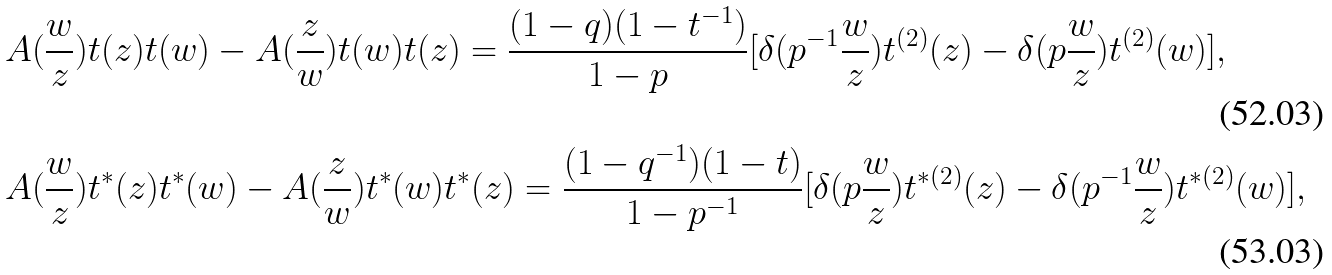Convert formula to latex. <formula><loc_0><loc_0><loc_500><loc_500>& A ( \frac { w } { z } ) t ( z ) t ( w ) - A ( \frac { z } { w } ) t ( w ) t ( z ) = \frac { ( 1 - q ) ( 1 - t ^ { - 1 } ) } { 1 - p } [ \delta ( p ^ { - 1 } \frac { w } { z } ) t ^ { ( 2 ) } ( z ) - \delta ( p \frac { w } { z } ) t ^ { ( 2 ) } ( w ) ] , \\ & A ( \frac { w } { z } ) t ^ { * } ( z ) t ^ { * } ( w ) - A ( \frac { z } { w } ) t ^ { * } ( w ) t ^ { * } ( z ) = \frac { ( 1 - q ^ { - 1 } ) ( 1 - t ) } { 1 - p ^ { - 1 } } [ \delta ( p \frac { w } { z } ) t ^ { * ( 2 ) } ( z ) - \delta ( p ^ { - 1 } \frac { w } { z } ) t ^ { * ( 2 ) } ( w ) ] ,</formula> 